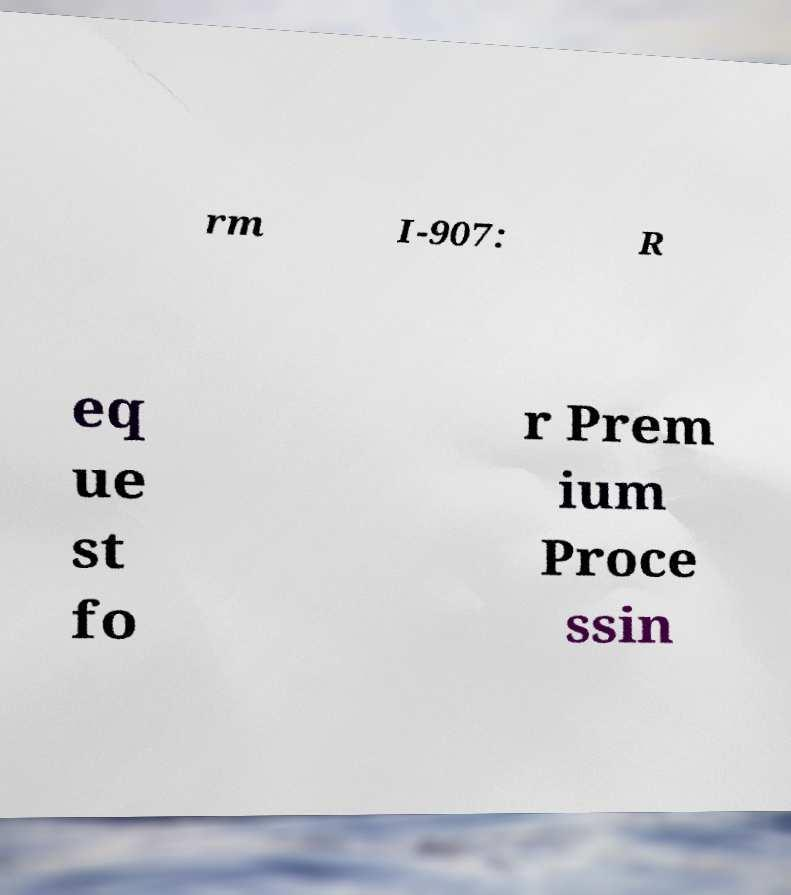Can you read and provide the text displayed in the image?This photo seems to have some interesting text. Can you extract and type it out for me? rm I-907: R eq ue st fo r Prem ium Proce ssin 